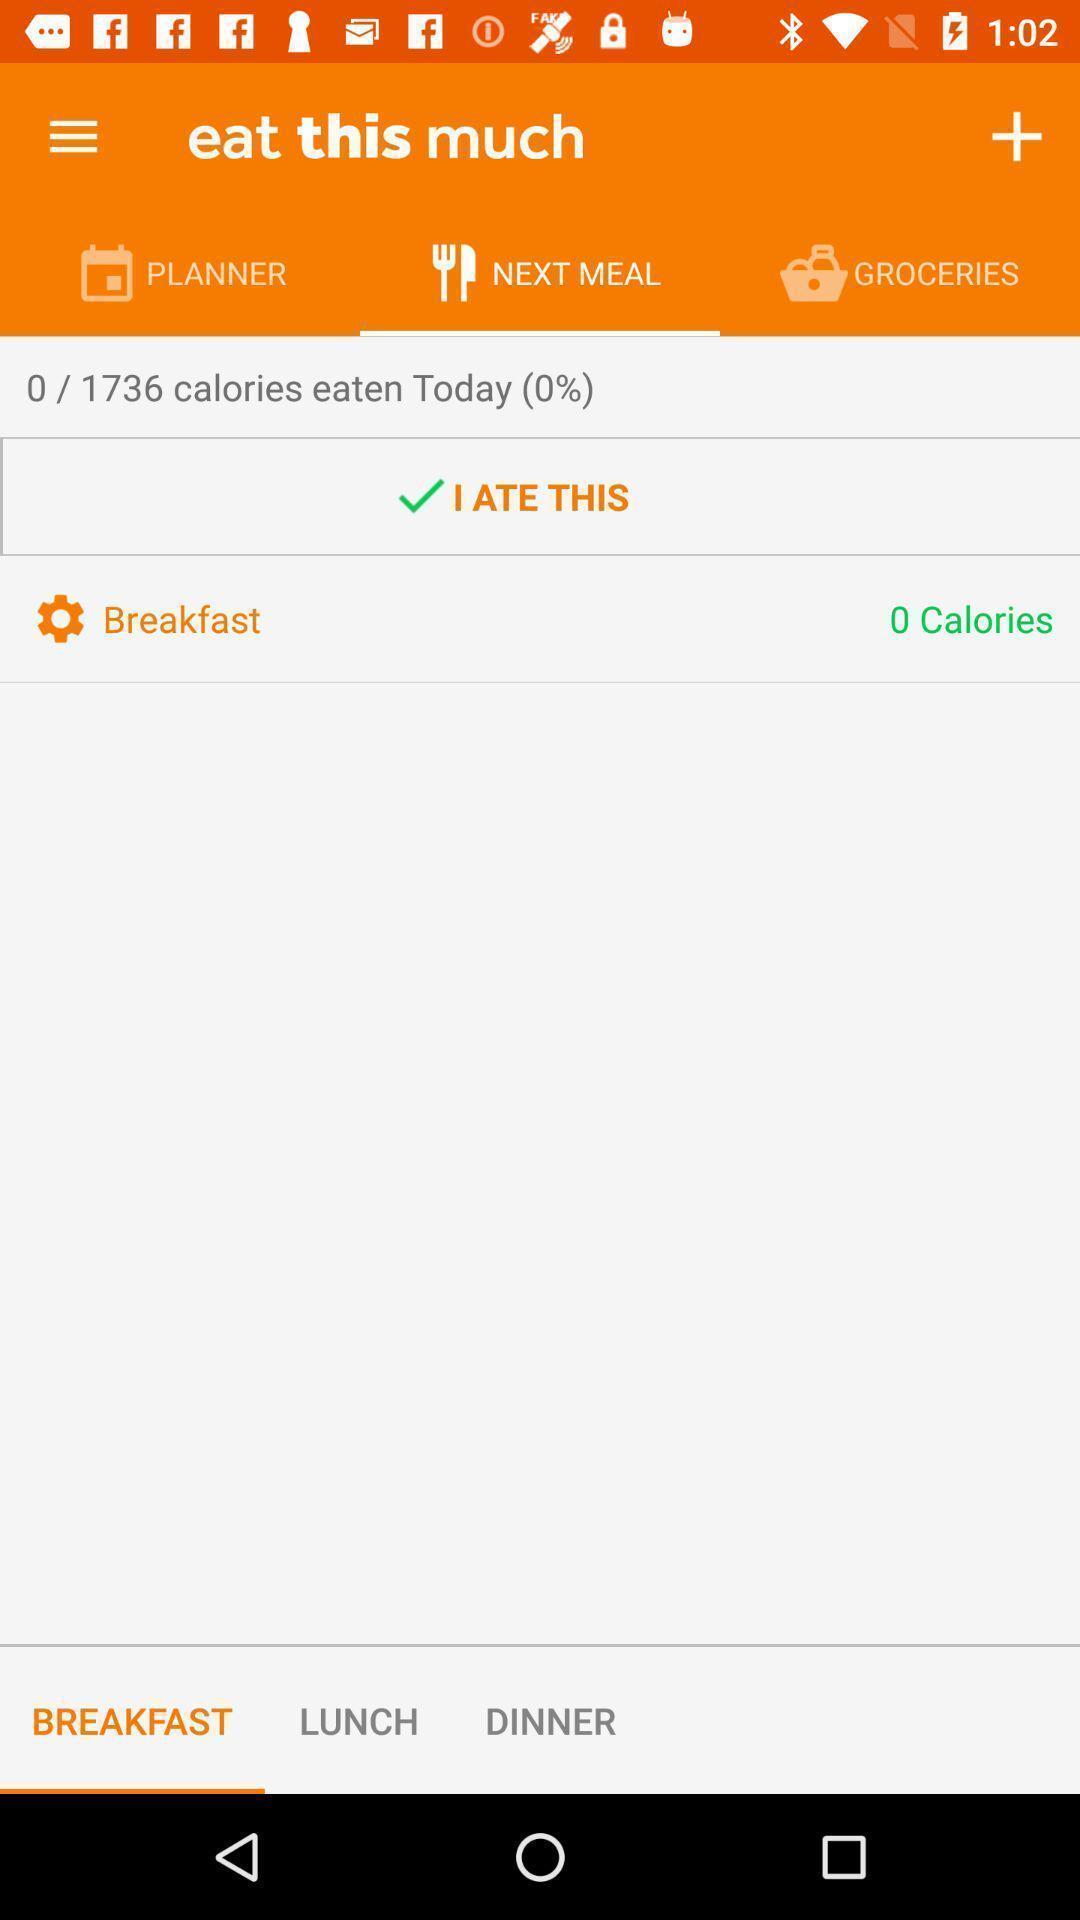What is the overall content of this screenshot? Screen shows about menu of next meal. 